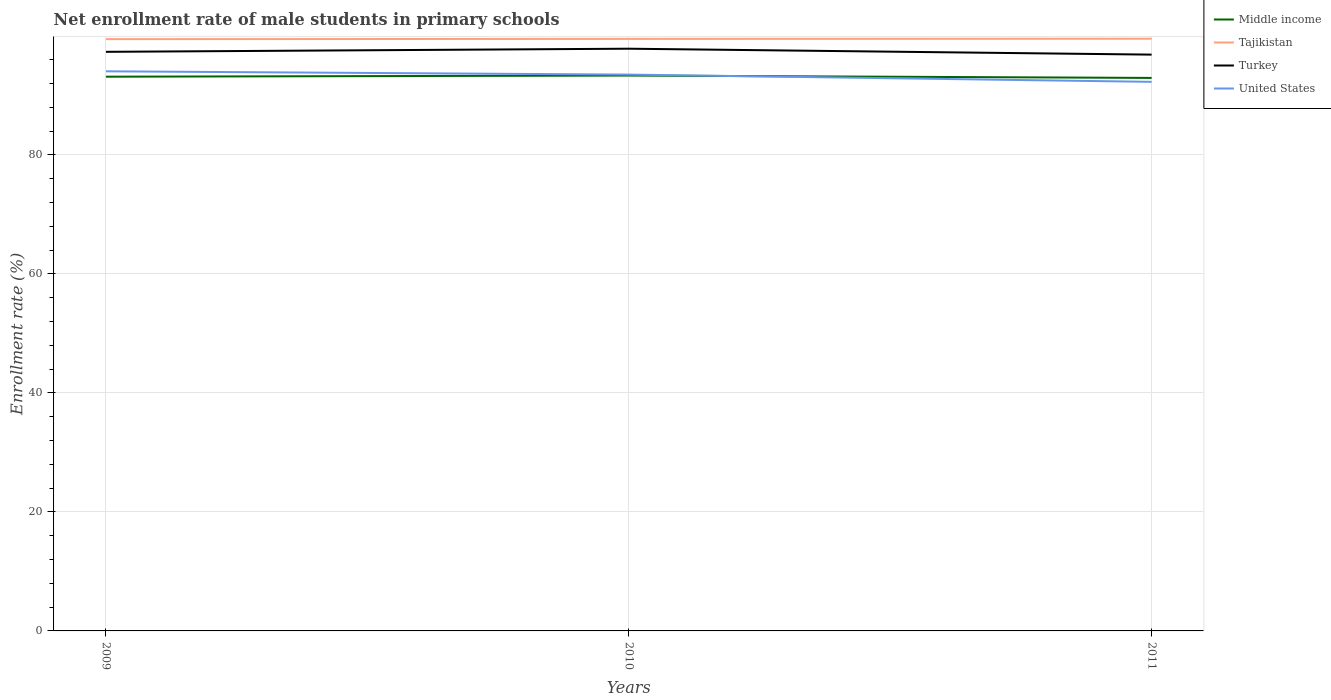How many different coloured lines are there?
Give a very brief answer. 4. Does the line corresponding to Middle income intersect with the line corresponding to Turkey?
Make the answer very short. No. Is the number of lines equal to the number of legend labels?
Offer a terse response. Yes. Across all years, what is the maximum net enrollment rate of male students in primary schools in Middle income?
Provide a succinct answer. 92.93. In which year was the net enrollment rate of male students in primary schools in Tajikistan maximum?
Your answer should be very brief. 2009. What is the total net enrollment rate of male students in primary schools in United States in the graph?
Provide a succinct answer. 0.55. What is the difference between the highest and the second highest net enrollment rate of male students in primary schools in United States?
Offer a very short reply. 1.77. Is the net enrollment rate of male students in primary schools in Middle income strictly greater than the net enrollment rate of male students in primary schools in Tajikistan over the years?
Your answer should be very brief. Yes. How many lines are there?
Give a very brief answer. 4. How many years are there in the graph?
Make the answer very short. 3. What is the difference between two consecutive major ticks on the Y-axis?
Keep it short and to the point. 20. Are the values on the major ticks of Y-axis written in scientific E-notation?
Ensure brevity in your answer.  No. Does the graph contain any zero values?
Make the answer very short. No. Does the graph contain grids?
Provide a short and direct response. Yes. Where does the legend appear in the graph?
Your answer should be very brief. Top right. How are the legend labels stacked?
Keep it short and to the point. Vertical. What is the title of the graph?
Ensure brevity in your answer.  Net enrollment rate of male students in primary schools. Does "Central African Republic" appear as one of the legend labels in the graph?
Your answer should be very brief. No. What is the label or title of the Y-axis?
Your response must be concise. Enrollment rate (%). What is the Enrollment rate (%) in Middle income in 2009?
Give a very brief answer. 93.14. What is the Enrollment rate (%) of Tajikistan in 2009?
Ensure brevity in your answer.  99.45. What is the Enrollment rate (%) of Turkey in 2009?
Offer a very short reply. 97.31. What is the Enrollment rate (%) in United States in 2009?
Offer a terse response. 94.04. What is the Enrollment rate (%) of Middle income in 2010?
Provide a short and direct response. 93.33. What is the Enrollment rate (%) in Tajikistan in 2010?
Give a very brief answer. 99.49. What is the Enrollment rate (%) of Turkey in 2010?
Your response must be concise. 97.84. What is the Enrollment rate (%) of United States in 2010?
Make the answer very short. 93.49. What is the Enrollment rate (%) in Middle income in 2011?
Offer a very short reply. 92.93. What is the Enrollment rate (%) in Tajikistan in 2011?
Your response must be concise. 99.51. What is the Enrollment rate (%) in Turkey in 2011?
Make the answer very short. 96.84. What is the Enrollment rate (%) in United States in 2011?
Give a very brief answer. 92.27. Across all years, what is the maximum Enrollment rate (%) in Middle income?
Provide a short and direct response. 93.33. Across all years, what is the maximum Enrollment rate (%) of Tajikistan?
Your answer should be very brief. 99.51. Across all years, what is the maximum Enrollment rate (%) of Turkey?
Your response must be concise. 97.84. Across all years, what is the maximum Enrollment rate (%) of United States?
Give a very brief answer. 94.04. Across all years, what is the minimum Enrollment rate (%) of Middle income?
Give a very brief answer. 92.93. Across all years, what is the minimum Enrollment rate (%) in Tajikistan?
Make the answer very short. 99.45. Across all years, what is the minimum Enrollment rate (%) in Turkey?
Ensure brevity in your answer.  96.84. Across all years, what is the minimum Enrollment rate (%) of United States?
Your answer should be very brief. 92.27. What is the total Enrollment rate (%) of Middle income in the graph?
Your answer should be compact. 279.39. What is the total Enrollment rate (%) of Tajikistan in the graph?
Provide a succinct answer. 298.45. What is the total Enrollment rate (%) of Turkey in the graph?
Your answer should be very brief. 291.99. What is the total Enrollment rate (%) in United States in the graph?
Your answer should be very brief. 279.8. What is the difference between the Enrollment rate (%) of Middle income in 2009 and that in 2010?
Your answer should be very brief. -0.19. What is the difference between the Enrollment rate (%) in Tajikistan in 2009 and that in 2010?
Make the answer very short. -0.04. What is the difference between the Enrollment rate (%) in Turkey in 2009 and that in 2010?
Provide a succinct answer. -0.53. What is the difference between the Enrollment rate (%) of United States in 2009 and that in 2010?
Offer a terse response. 0.55. What is the difference between the Enrollment rate (%) of Middle income in 2009 and that in 2011?
Make the answer very short. 0.21. What is the difference between the Enrollment rate (%) in Tajikistan in 2009 and that in 2011?
Give a very brief answer. -0.07. What is the difference between the Enrollment rate (%) in Turkey in 2009 and that in 2011?
Give a very brief answer. 0.47. What is the difference between the Enrollment rate (%) of United States in 2009 and that in 2011?
Your response must be concise. 1.77. What is the difference between the Enrollment rate (%) in Middle income in 2010 and that in 2011?
Provide a succinct answer. 0.4. What is the difference between the Enrollment rate (%) of Tajikistan in 2010 and that in 2011?
Make the answer very short. -0.03. What is the difference between the Enrollment rate (%) in United States in 2010 and that in 2011?
Provide a succinct answer. 1.22. What is the difference between the Enrollment rate (%) in Middle income in 2009 and the Enrollment rate (%) in Tajikistan in 2010?
Give a very brief answer. -6.35. What is the difference between the Enrollment rate (%) of Middle income in 2009 and the Enrollment rate (%) of Turkey in 2010?
Your response must be concise. -4.7. What is the difference between the Enrollment rate (%) of Middle income in 2009 and the Enrollment rate (%) of United States in 2010?
Your answer should be very brief. -0.35. What is the difference between the Enrollment rate (%) in Tajikistan in 2009 and the Enrollment rate (%) in Turkey in 2010?
Provide a short and direct response. 1.61. What is the difference between the Enrollment rate (%) in Tajikistan in 2009 and the Enrollment rate (%) in United States in 2010?
Provide a short and direct response. 5.96. What is the difference between the Enrollment rate (%) of Turkey in 2009 and the Enrollment rate (%) of United States in 2010?
Provide a short and direct response. 3.83. What is the difference between the Enrollment rate (%) in Middle income in 2009 and the Enrollment rate (%) in Tajikistan in 2011?
Your answer should be compact. -6.38. What is the difference between the Enrollment rate (%) in Middle income in 2009 and the Enrollment rate (%) in Turkey in 2011?
Provide a succinct answer. -3.71. What is the difference between the Enrollment rate (%) of Middle income in 2009 and the Enrollment rate (%) of United States in 2011?
Your answer should be compact. 0.87. What is the difference between the Enrollment rate (%) in Tajikistan in 2009 and the Enrollment rate (%) in Turkey in 2011?
Your response must be concise. 2.61. What is the difference between the Enrollment rate (%) in Tajikistan in 2009 and the Enrollment rate (%) in United States in 2011?
Give a very brief answer. 7.18. What is the difference between the Enrollment rate (%) in Turkey in 2009 and the Enrollment rate (%) in United States in 2011?
Your response must be concise. 5.05. What is the difference between the Enrollment rate (%) of Middle income in 2010 and the Enrollment rate (%) of Tajikistan in 2011?
Your response must be concise. -6.19. What is the difference between the Enrollment rate (%) in Middle income in 2010 and the Enrollment rate (%) in Turkey in 2011?
Your response must be concise. -3.51. What is the difference between the Enrollment rate (%) in Middle income in 2010 and the Enrollment rate (%) in United States in 2011?
Provide a short and direct response. 1.06. What is the difference between the Enrollment rate (%) of Tajikistan in 2010 and the Enrollment rate (%) of Turkey in 2011?
Make the answer very short. 2.64. What is the difference between the Enrollment rate (%) in Tajikistan in 2010 and the Enrollment rate (%) in United States in 2011?
Provide a short and direct response. 7.22. What is the difference between the Enrollment rate (%) of Turkey in 2010 and the Enrollment rate (%) of United States in 2011?
Make the answer very short. 5.57. What is the average Enrollment rate (%) of Middle income per year?
Offer a terse response. 93.13. What is the average Enrollment rate (%) of Tajikistan per year?
Provide a succinct answer. 99.48. What is the average Enrollment rate (%) in Turkey per year?
Make the answer very short. 97.33. What is the average Enrollment rate (%) in United States per year?
Your answer should be very brief. 93.27. In the year 2009, what is the difference between the Enrollment rate (%) of Middle income and Enrollment rate (%) of Tajikistan?
Give a very brief answer. -6.31. In the year 2009, what is the difference between the Enrollment rate (%) of Middle income and Enrollment rate (%) of Turkey?
Offer a terse response. -4.18. In the year 2009, what is the difference between the Enrollment rate (%) of Middle income and Enrollment rate (%) of United States?
Make the answer very short. -0.91. In the year 2009, what is the difference between the Enrollment rate (%) in Tajikistan and Enrollment rate (%) in Turkey?
Provide a short and direct response. 2.13. In the year 2009, what is the difference between the Enrollment rate (%) of Tajikistan and Enrollment rate (%) of United States?
Keep it short and to the point. 5.41. In the year 2009, what is the difference between the Enrollment rate (%) in Turkey and Enrollment rate (%) in United States?
Provide a short and direct response. 3.27. In the year 2010, what is the difference between the Enrollment rate (%) in Middle income and Enrollment rate (%) in Tajikistan?
Make the answer very short. -6.16. In the year 2010, what is the difference between the Enrollment rate (%) in Middle income and Enrollment rate (%) in Turkey?
Your answer should be compact. -4.51. In the year 2010, what is the difference between the Enrollment rate (%) of Middle income and Enrollment rate (%) of United States?
Offer a very short reply. -0.16. In the year 2010, what is the difference between the Enrollment rate (%) of Tajikistan and Enrollment rate (%) of Turkey?
Ensure brevity in your answer.  1.65. In the year 2010, what is the difference between the Enrollment rate (%) of Tajikistan and Enrollment rate (%) of United States?
Give a very brief answer. 6. In the year 2010, what is the difference between the Enrollment rate (%) in Turkey and Enrollment rate (%) in United States?
Give a very brief answer. 4.35. In the year 2011, what is the difference between the Enrollment rate (%) of Middle income and Enrollment rate (%) of Tajikistan?
Provide a succinct answer. -6.58. In the year 2011, what is the difference between the Enrollment rate (%) in Middle income and Enrollment rate (%) in Turkey?
Keep it short and to the point. -3.91. In the year 2011, what is the difference between the Enrollment rate (%) in Middle income and Enrollment rate (%) in United States?
Your answer should be compact. 0.66. In the year 2011, what is the difference between the Enrollment rate (%) of Tajikistan and Enrollment rate (%) of Turkey?
Make the answer very short. 2.67. In the year 2011, what is the difference between the Enrollment rate (%) in Tajikistan and Enrollment rate (%) in United States?
Keep it short and to the point. 7.25. In the year 2011, what is the difference between the Enrollment rate (%) of Turkey and Enrollment rate (%) of United States?
Offer a very short reply. 4.57. What is the ratio of the Enrollment rate (%) in United States in 2009 to that in 2010?
Provide a short and direct response. 1.01. What is the ratio of the Enrollment rate (%) of Tajikistan in 2009 to that in 2011?
Provide a short and direct response. 1. What is the ratio of the Enrollment rate (%) in Turkey in 2009 to that in 2011?
Your answer should be compact. 1. What is the ratio of the Enrollment rate (%) in United States in 2009 to that in 2011?
Your answer should be very brief. 1.02. What is the ratio of the Enrollment rate (%) of Middle income in 2010 to that in 2011?
Make the answer very short. 1. What is the ratio of the Enrollment rate (%) of Turkey in 2010 to that in 2011?
Provide a succinct answer. 1.01. What is the ratio of the Enrollment rate (%) of United States in 2010 to that in 2011?
Provide a succinct answer. 1.01. What is the difference between the highest and the second highest Enrollment rate (%) in Middle income?
Your response must be concise. 0.19. What is the difference between the highest and the second highest Enrollment rate (%) in Tajikistan?
Make the answer very short. 0.03. What is the difference between the highest and the second highest Enrollment rate (%) in Turkey?
Make the answer very short. 0.53. What is the difference between the highest and the second highest Enrollment rate (%) in United States?
Keep it short and to the point. 0.55. What is the difference between the highest and the lowest Enrollment rate (%) in Middle income?
Make the answer very short. 0.4. What is the difference between the highest and the lowest Enrollment rate (%) of Tajikistan?
Give a very brief answer. 0.07. What is the difference between the highest and the lowest Enrollment rate (%) in United States?
Your response must be concise. 1.77. 